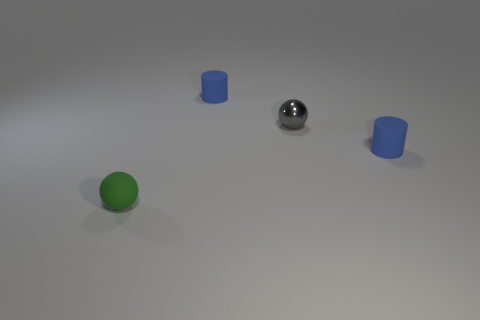Subtract 0 green cubes. How many objects are left? 4 Subtract 1 balls. How many balls are left? 1 Subtract all brown cylinders. Subtract all green blocks. How many cylinders are left? 2 Subtract all cyan cylinders. How many gray spheres are left? 1 Subtract all small gray matte cubes. Subtract all small matte things. How many objects are left? 1 Add 4 tiny matte cylinders. How many tiny matte cylinders are left? 6 Add 1 green rubber spheres. How many green rubber spheres exist? 2 Add 4 balls. How many objects exist? 8 Subtract all gray spheres. How many spheres are left? 1 